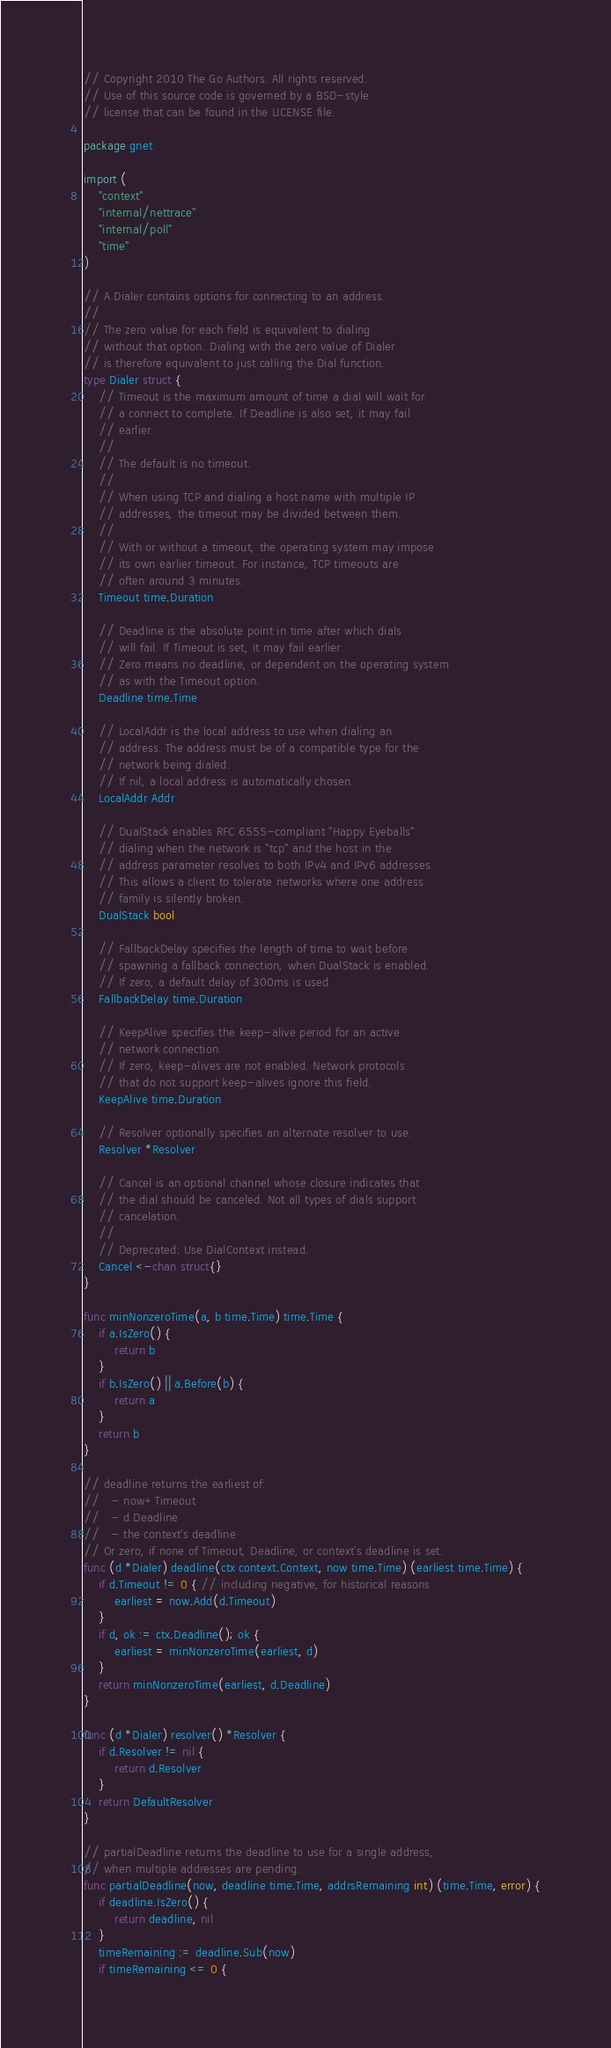Convert code to text. <code><loc_0><loc_0><loc_500><loc_500><_Go_>// Copyright 2010 The Go Authors. All rights reserved.
// Use of this source code is governed by a BSD-style
// license that can be found in the LICENSE file.

package gnet

import (
	"context"
	"internal/nettrace"
	"internal/poll"
	"time"
)

// A Dialer contains options for connecting to an address.
//
// The zero value for each field is equivalent to dialing
// without that option. Dialing with the zero value of Dialer
// is therefore equivalent to just calling the Dial function.
type Dialer struct {
	// Timeout is the maximum amount of time a dial will wait for
	// a connect to complete. If Deadline is also set, it may fail
	// earlier.
	//
	// The default is no timeout.
	//
	// When using TCP and dialing a host name with multiple IP
	// addresses, the timeout may be divided between them.
	//
	// With or without a timeout, the operating system may impose
	// its own earlier timeout. For instance, TCP timeouts are
	// often around 3 minutes.
	Timeout time.Duration

	// Deadline is the absolute point in time after which dials
	// will fail. If Timeout is set, it may fail earlier.
	// Zero means no deadline, or dependent on the operating system
	// as with the Timeout option.
	Deadline time.Time

	// LocalAddr is the local address to use when dialing an
	// address. The address must be of a compatible type for the
	// network being dialed.
	// If nil, a local address is automatically chosen.
	LocalAddr Addr

	// DualStack enables RFC 6555-compliant "Happy Eyeballs"
	// dialing when the network is "tcp" and the host in the
	// address parameter resolves to both IPv4 and IPv6 addresses.
	// This allows a client to tolerate networks where one address
	// family is silently broken.
	DualStack bool

	// FallbackDelay specifies the length of time to wait before
	// spawning a fallback connection, when DualStack is enabled.
	// If zero, a default delay of 300ms is used.
	FallbackDelay time.Duration

	// KeepAlive specifies the keep-alive period for an active
	// network connection.
	// If zero, keep-alives are not enabled. Network protocols
	// that do not support keep-alives ignore this field.
	KeepAlive time.Duration

	// Resolver optionally specifies an alternate resolver to use.
	Resolver *Resolver

	// Cancel is an optional channel whose closure indicates that
	// the dial should be canceled. Not all types of dials support
	// cancelation.
	//
	// Deprecated: Use DialContext instead.
	Cancel <-chan struct{}
}

func minNonzeroTime(a, b time.Time) time.Time {
	if a.IsZero() {
		return b
	}
	if b.IsZero() || a.Before(b) {
		return a
	}
	return b
}

// deadline returns the earliest of:
//   - now+Timeout
//   - d.Deadline
//   - the context's deadline
// Or zero, if none of Timeout, Deadline, or context's deadline is set.
func (d *Dialer) deadline(ctx context.Context, now time.Time) (earliest time.Time) {
	if d.Timeout != 0 { // including negative, for historical reasons
		earliest = now.Add(d.Timeout)
	}
	if d, ok := ctx.Deadline(); ok {
		earliest = minNonzeroTime(earliest, d)
	}
	return minNonzeroTime(earliest, d.Deadline)
}

func (d *Dialer) resolver() *Resolver {
	if d.Resolver != nil {
		return d.Resolver
	}
	return DefaultResolver
}

// partialDeadline returns the deadline to use for a single address,
// when multiple addresses are pending.
func partialDeadline(now, deadline time.Time, addrsRemaining int) (time.Time, error) {
	if deadline.IsZero() {
		return deadline, nil
	}
	timeRemaining := deadline.Sub(now)
	if timeRemaining <= 0 {</code> 